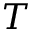<formula> <loc_0><loc_0><loc_500><loc_500>T</formula> 